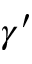<formula> <loc_0><loc_0><loc_500><loc_500>\gamma ^ { \prime }</formula> 